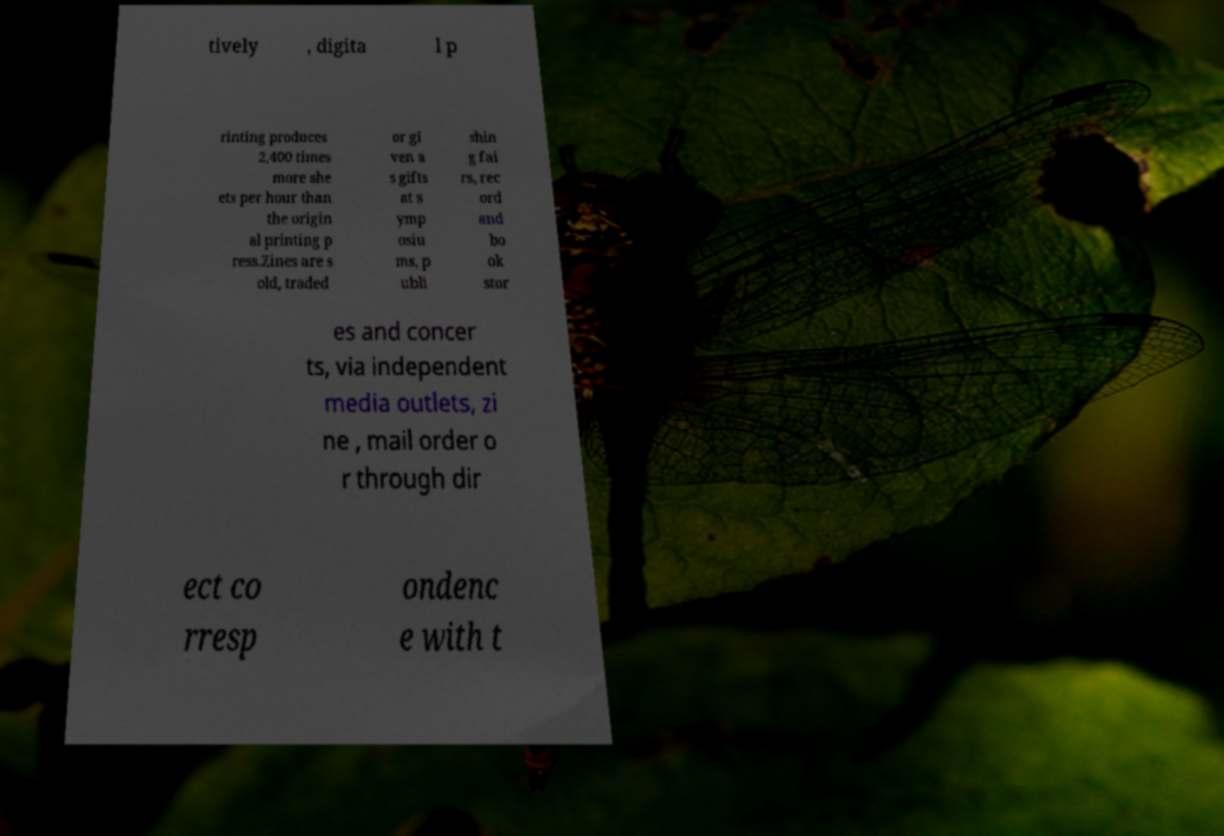Can you accurately transcribe the text from the provided image for me? tively , digita l p rinting produces 2,400 times more she ets per hour than the origin al printing p ress.Zines are s old, traded or gi ven a s gifts at s ymp osiu ms, p ubli shin g fai rs, rec ord and bo ok stor es and concer ts, via independent media outlets, zi ne , mail order o r through dir ect co rresp ondenc e with t 